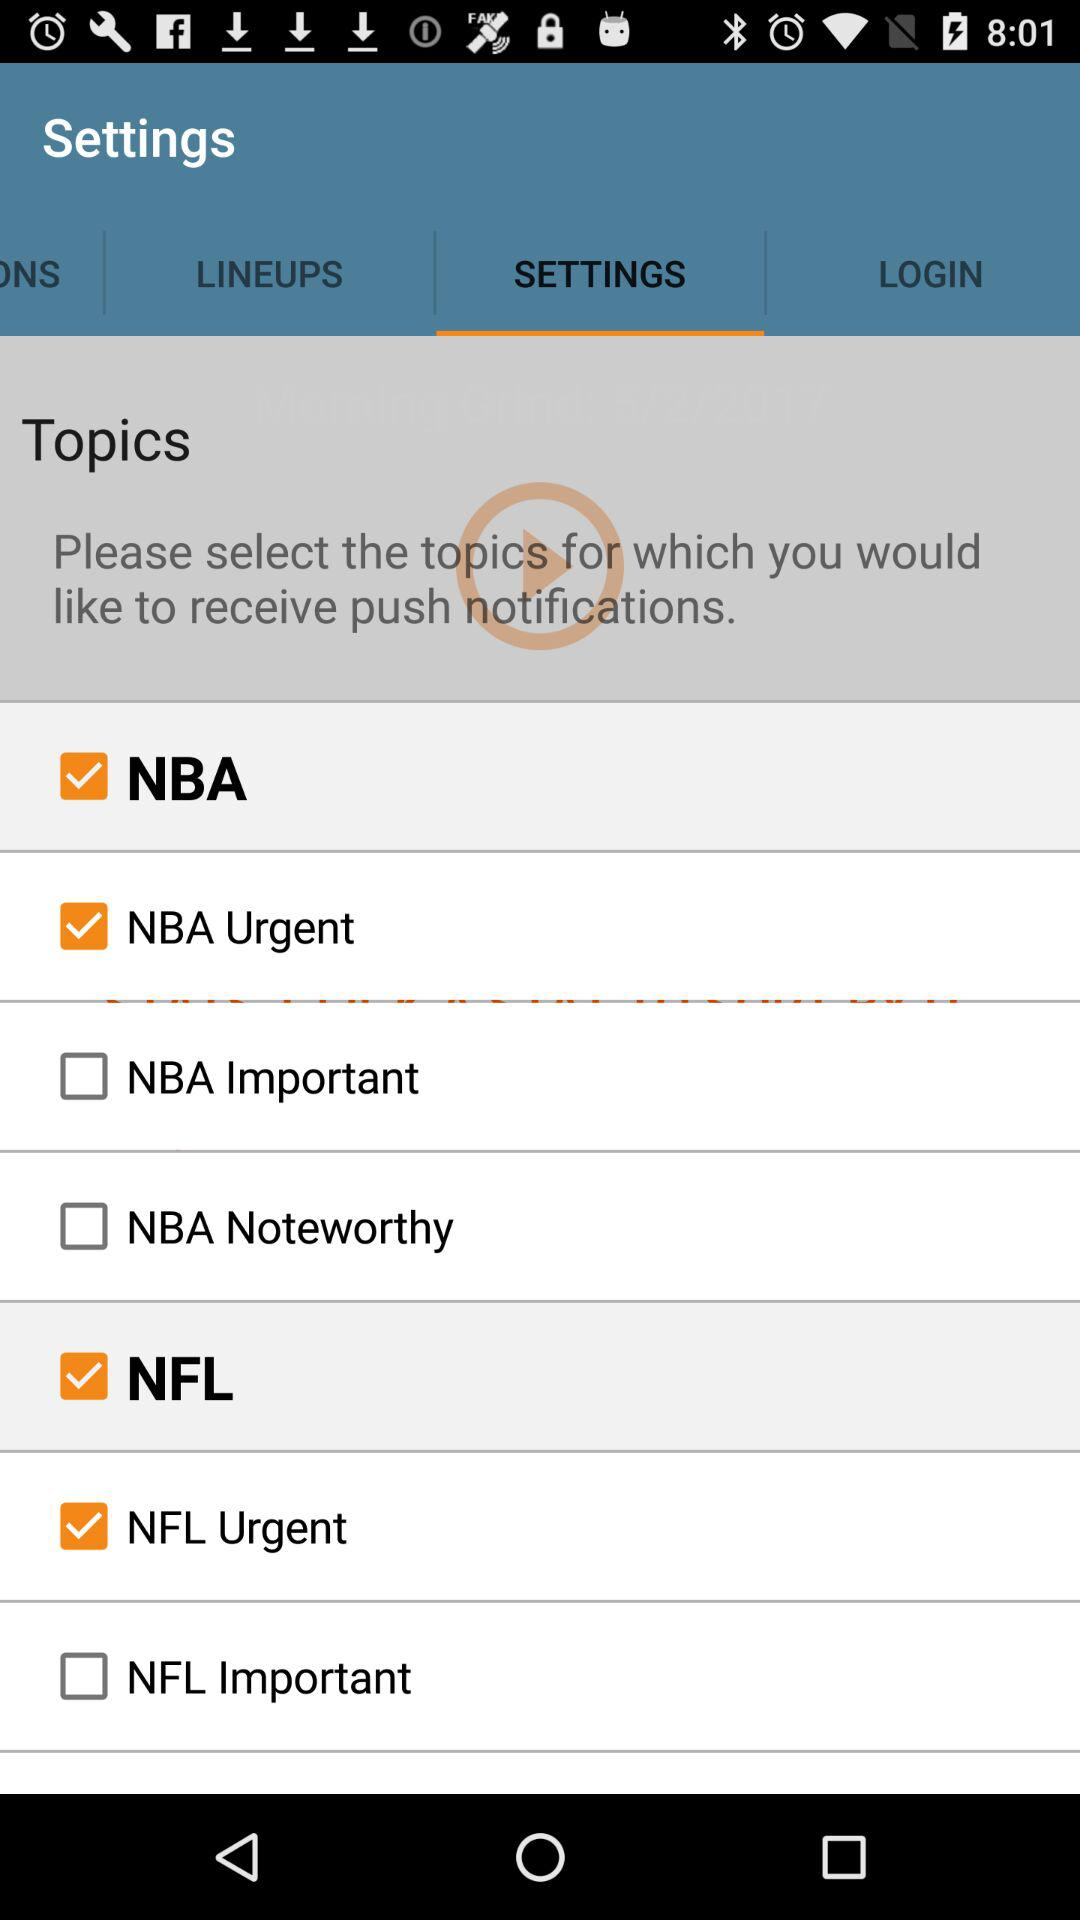What tab is selected? The selected tab is "SETTINGS". 